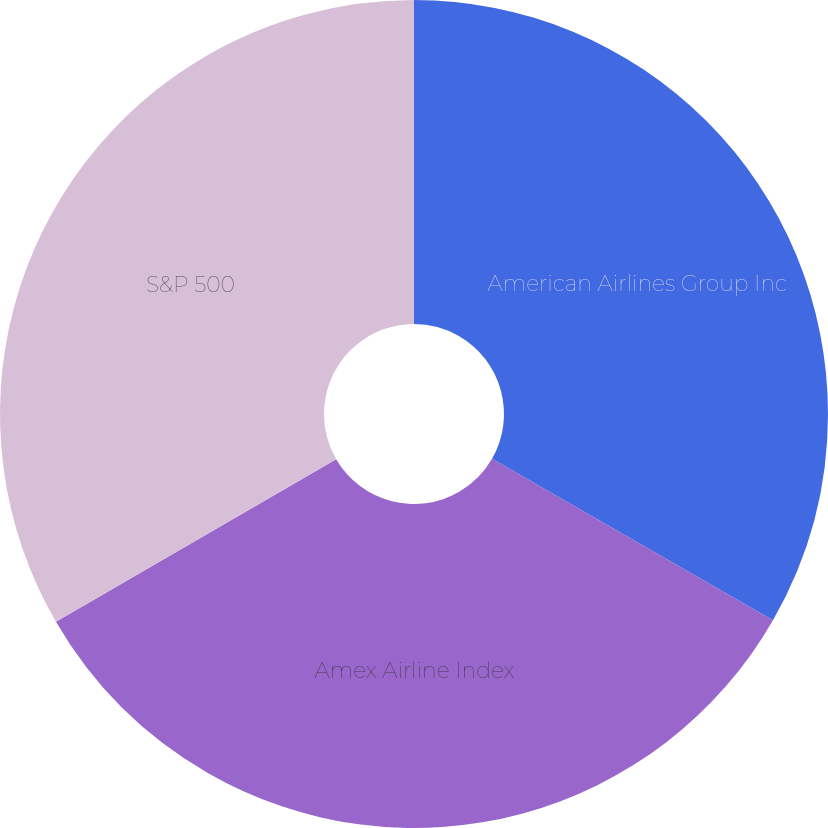<chart> <loc_0><loc_0><loc_500><loc_500><pie_chart><fcel>American Airlines Group Inc<fcel>Amex Airline Index<fcel>S&P 500<nl><fcel>33.3%<fcel>33.33%<fcel>33.37%<nl></chart> 